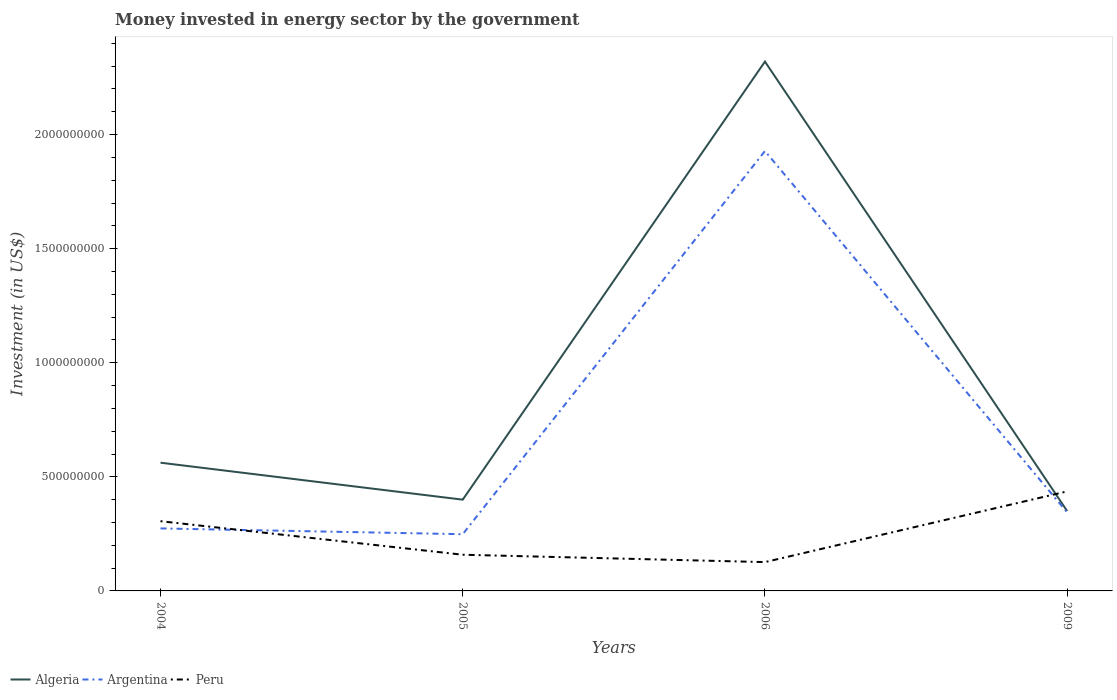Does the line corresponding to Peru intersect with the line corresponding to Algeria?
Your answer should be compact. Yes. Across all years, what is the maximum money spent in energy sector in Peru?
Provide a succinct answer. 1.26e+08. What is the total money spent in energy sector in Algeria in the graph?
Make the answer very short. 2.12e+08. What is the difference between the highest and the second highest money spent in energy sector in Peru?
Keep it short and to the point. 3.10e+08. Does the graph contain any zero values?
Make the answer very short. No. What is the title of the graph?
Provide a succinct answer. Money invested in energy sector by the government. What is the label or title of the Y-axis?
Offer a very short reply. Investment (in US$). What is the Investment (in US$) in Algeria in 2004?
Provide a short and direct response. 5.62e+08. What is the Investment (in US$) in Argentina in 2004?
Provide a short and direct response. 2.74e+08. What is the Investment (in US$) in Peru in 2004?
Ensure brevity in your answer.  3.06e+08. What is the Investment (in US$) in Algeria in 2005?
Your answer should be compact. 4.00e+08. What is the Investment (in US$) of Argentina in 2005?
Keep it short and to the point. 2.49e+08. What is the Investment (in US$) in Peru in 2005?
Offer a terse response. 1.59e+08. What is the Investment (in US$) of Algeria in 2006?
Your answer should be compact. 2.32e+09. What is the Investment (in US$) of Argentina in 2006?
Offer a terse response. 1.93e+09. What is the Investment (in US$) of Peru in 2006?
Give a very brief answer. 1.26e+08. What is the Investment (in US$) in Algeria in 2009?
Make the answer very short. 3.50e+08. What is the Investment (in US$) of Argentina in 2009?
Your answer should be compact. 3.44e+08. What is the Investment (in US$) in Peru in 2009?
Your answer should be very brief. 4.36e+08. Across all years, what is the maximum Investment (in US$) in Algeria?
Ensure brevity in your answer.  2.32e+09. Across all years, what is the maximum Investment (in US$) in Argentina?
Ensure brevity in your answer.  1.93e+09. Across all years, what is the maximum Investment (in US$) of Peru?
Offer a very short reply. 4.36e+08. Across all years, what is the minimum Investment (in US$) in Algeria?
Your answer should be compact. 3.50e+08. Across all years, what is the minimum Investment (in US$) of Argentina?
Offer a terse response. 2.49e+08. Across all years, what is the minimum Investment (in US$) of Peru?
Offer a very short reply. 1.26e+08. What is the total Investment (in US$) in Algeria in the graph?
Keep it short and to the point. 3.63e+09. What is the total Investment (in US$) of Argentina in the graph?
Offer a very short reply. 2.79e+09. What is the total Investment (in US$) of Peru in the graph?
Offer a very short reply. 1.03e+09. What is the difference between the Investment (in US$) of Algeria in 2004 and that in 2005?
Ensure brevity in your answer.  1.62e+08. What is the difference between the Investment (in US$) of Argentina in 2004 and that in 2005?
Make the answer very short. 2.54e+07. What is the difference between the Investment (in US$) of Peru in 2004 and that in 2005?
Provide a short and direct response. 1.47e+08. What is the difference between the Investment (in US$) in Algeria in 2004 and that in 2006?
Your response must be concise. -1.76e+09. What is the difference between the Investment (in US$) in Argentina in 2004 and that in 2006?
Keep it short and to the point. -1.65e+09. What is the difference between the Investment (in US$) of Peru in 2004 and that in 2006?
Your answer should be compact. 1.79e+08. What is the difference between the Investment (in US$) in Algeria in 2004 and that in 2009?
Ensure brevity in your answer.  2.12e+08. What is the difference between the Investment (in US$) in Argentina in 2004 and that in 2009?
Give a very brief answer. -7.02e+07. What is the difference between the Investment (in US$) of Peru in 2004 and that in 2009?
Ensure brevity in your answer.  -1.31e+08. What is the difference between the Investment (in US$) of Algeria in 2005 and that in 2006?
Make the answer very short. -1.92e+09. What is the difference between the Investment (in US$) in Argentina in 2005 and that in 2006?
Offer a very short reply. -1.68e+09. What is the difference between the Investment (in US$) of Peru in 2005 and that in 2006?
Your answer should be very brief. 3.23e+07. What is the difference between the Investment (in US$) in Argentina in 2005 and that in 2009?
Your response must be concise. -9.56e+07. What is the difference between the Investment (in US$) of Peru in 2005 and that in 2009?
Your answer should be compact. -2.78e+08. What is the difference between the Investment (in US$) of Algeria in 2006 and that in 2009?
Give a very brief answer. 1.97e+09. What is the difference between the Investment (in US$) of Argentina in 2006 and that in 2009?
Give a very brief answer. 1.58e+09. What is the difference between the Investment (in US$) in Peru in 2006 and that in 2009?
Your response must be concise. -3.10e+08. What is the difference between the Investment (in US$) of Algeria in 2004 and the Investment (in US$) of Argentina in 2005?
Your answer should be compact. 3.13e+08. What is the difference between the Investment (in US$) in Algeria in 2004 and the Investment (in US$) in Peru in 2005?
Provide a short and direct response. 4.03e+08. What is the difference between the Investment (in US$) in Argentina in 2004 and the Investment (in US$) in Peru in 2005?
Your answer should be compact. 1.15e+08. What is the difference between the Investment (in US$) of Algeria in 2004 and the Investment (in US$) of Argentina in 2006?
Your response must be concise. -1.37e+09. What is the difference between the Investment (in US$) of Algeria in 2004 and the Investment (in US$) of Peru in 2006?
Your response must be concise. 4.36e+08. What is the difference between the Investment (in US$) in Argentina in 2004 and the Investment (in US$) in Peru in 2006?
Give a very brief answer. 1.48e+08. What is the difference between the Investment (in US$) in Algeria in 2004 and the Investment (in US$) in Argentina in 2009?
Make the answer very short. 2.18e+08. What is the difference between the Investment (in US$) in Algeria in 2004 and the Investment (in US$) in Peru in 2009?
Ensure brevity in your answer.  1.26e+08. What is the difference between the Investment (in US$) of Argentina in 2004 and the Investment (in US$) of Peru in 2009?
Ensure brevity in your answer.  -1.62e+08. What is the difference between the Investment (in US$) in Algeria in 2005 and the Investment (in US$) in Argentina in 2006?
Provide a short and direct response. -1.53e+09. What is the difference between the Investment (in US$) in Algeria in 2005 and the Investment (in US$) in Peru in 2006?
Your response must be concise. 2.74e+08. What is the difference between the Investment (in US$) of Argentina in 2005 and the Investment (in US$) of Peru in 2006?
Offer a terse response. 1.22e+08. What is the difference between the Investment (in US$) in Algeria in 2005 and the Investment (in US$) in Argentina in 2009?
Your answer should be compact. 5.58e+07. What is the difference between the Investment (in US$) in Algeria in 2005 and the Investment (in US$) in Peru in 2009?
Give a very brief answer. -3.63e+07. What is the difference between the Investment (in US$) in Argentina in 2005 and the Investment (in US$) in Peru in 2009?
Provide a short and direct response. -1.88e+08. What is the difference between the Investment (in US$) in Algeria in 2006 and the Investment (in US$) in Argentina in 2009?
Your answer should be very brief. 1.98e+09. What is the difference between the Investment (in US$) of Algeria in 2006 and the Investment (in US$) of Peru in 2009?
Offer a terse response. 1.88e+09. What is the difference between the Investment (in US$) in Argentina in 2006 and the Investment (in US$) in Peru in 2009?
Ensure brevity in your answer.  1.49e+09. What is the average Investment (in US$) in Algeria per year?
Keep it short and to the point. 9.08e+08. What is the average Investment (in US$) of Argentina per year?
Make the answer very short. 6.99e+08. What is the average Investment (in US$) of Peru per year?
Provide a short and direct response. 2.57e+08. In the year 2004, what is the difference between the Investment (in US$) in Algeria and Investment (in US$) in Argentina?
Offer a very short reply. 2.88e+08. In the year 2004, what is the difference between the Investment (in US$) in Algeria and Investment (in US$) in Peru?
Keep it short and to the point. 2.56e+08. In the year 2004, what is the difference between the Investment (in US$) in Argentina and Investment (in US$) in Peru?
Your answer should be very brief. -3.16e+07. In the year 2005, what is the difference between the Investment (in US$) of Algeria and Investment (in US$) of Argentina?
Your response must be concise. 1.51e+08. In the year 2005, what is the difference between the Investment (in US$) of Algeria and Investment (in US$) of Peru?
Keep it short and to the point. 2.41e+08. In the year 2005, what is the difference between the Investment (in US$) of Argentina and Investment (in US$) of Peru?
Your answer should be very brief. 9.00e+07. In the year 2006, what is the difference between the Investment (in US$) of Algeria and Investment (in US$) of Argentina?
Your response must be concise. 3.92e+08. In the year 2006, what is the difference between the Investment (in US$) of Algeria and Investment (in US$) of Peru?
Provide a short and direct response. 2.19e+09. In the year 2006, what is the difference between the Investment (in US$) of Argentina and Investment (in US$) of Peru?
Your response must be concise. 1.80e+09. In the year 2009, what is the difference between the Investment (in US$) in Algeria and Investment (in US$) in Argentina?
Your answer should be very brief. 5.75e+06. In the year 2009, what is the difference between the Investment (in US$) of Algeria and Investment (in US$) of Peru?
Your answer should be very brief. -8.63e+07. In the year 2009, what is the difference between the Investment (in US$) of Argentina and Investment (in US$) of Peru?
Your response must be concise. -9.20e+07. What is the ratio of the Investment (in US$) of Algeria in 2004 to that in 2005?
Provide a succinct answer. 1.41. What is the ratio of the Investment (in US$) of Argentina in 2004 to that in 2005?
Keep it short and to the point. 1.1. What is the ratio of the Investment (in US$) in Peru in 2004 to that in 2005?
Make the answer very short. 1.93. What is the ratio of the Investment (in US$) in Algeria in 2004 to that in 2006?
Your response must be concise. 0.24. What is the ratio of the Investment (in US$) in Argentina in 2004 to that in 2006?
Provide a short and direct response. 0.14. What is the ratio of the Investment (in US$) of Peru in 2004 to that in 2006?
Your answer should be compact. 2.42. What is the ratio of the Investment (in US$) in Algeria in 2004 to that in 2009?
Give a very brief answer. 1.61. What is the ratio of the Investment (in US$) of Argentina in 2004 to that in 2009?
Your answer should be very brief. 0.8. What is the ratio of the Investment (in US$) in Peru in 2004 to that in 2009?
Your answer should be compact. 0.7. What is the ratio of the Investment (in US$) in Algeria in 2005 to that in 2006?
Make the answer very short. 0.17. What is the ratio of the Investment (in US$) in Argentina in 2005 to that in 2006?
Your response must be concise. 0.13. What is the ratio of the Investment (in US$) of Peru in 2005 to that in 2006?
Offer a very short reply. 1.26. What is the ratio of the Investment (in US$) of Algeria in 2005 to that in 2009?
Offer a terse response. 1.14. What is the ratio of the Investment (in US$) in Argentina in 2005 to that in 2009?
Your response must be concise. 0.72. What is the ratio of the Investment (in US$) in Peru in 2005 to that in 2009?
Offer a terse response. 0.36. What is the ratio of the Investment (in US$) in Algeria in 2006 to that in 2009?
Give a very brief answer. 6.63. What is the ratio of the Investment (in US$) in Argentina in 2006 to that in 2009?
Ensure brevity in your answer.  5.6. What is the ratio of the Investment (in US$) of Peru in 2006 to that in 2009?
Ensure brevity in your answer.  0.29. What is the difference between the highest and the second highest Investment (in US$) of Algeria?
Make the answer very short. 1.76e+09. What is the difference between the highest and the second highest Investment (in US$) in Argentina?
Your response must be concise. 1.58e+09. What is the difference between the highest and the second highest Investment (in US$) of Peru?
Your answer should be very brief. 1.31e+08. What is the difference between the highest and the lowest Investment (in US$) of Algeria?
Offer a terse response. 1.97e+09. What is the difference between the highest and the lowest Investment (in US$) in Argentina?
Ensure brevity in your answer.  1.68e+09. What is the difference between the highest and the lowest Investment (in US$) in Peru?
Ensure brevity in your answer.  3.10e+08. 